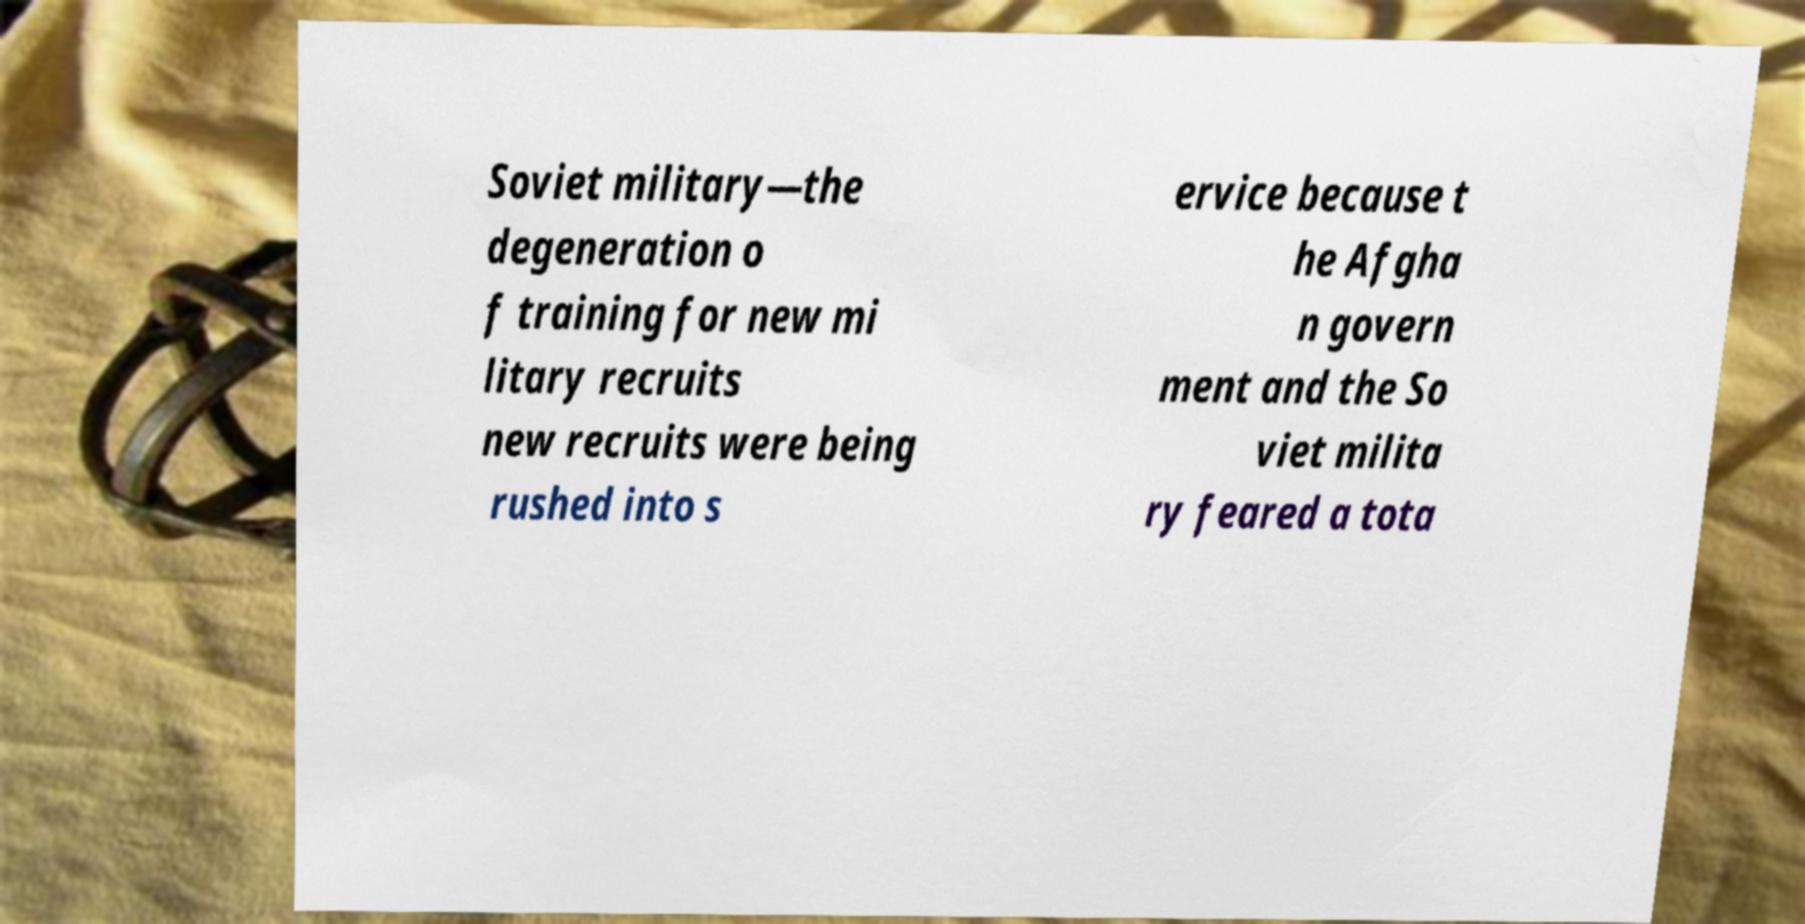There's text embedded in this image that I need extracted. Can you transcribe it verbatim? Soviet military—the degeneration o f training for new mi litary recruits new recruits were being rushed into s ervice because t he Afgha n govern ment and the So viet milita ry feared a tota 